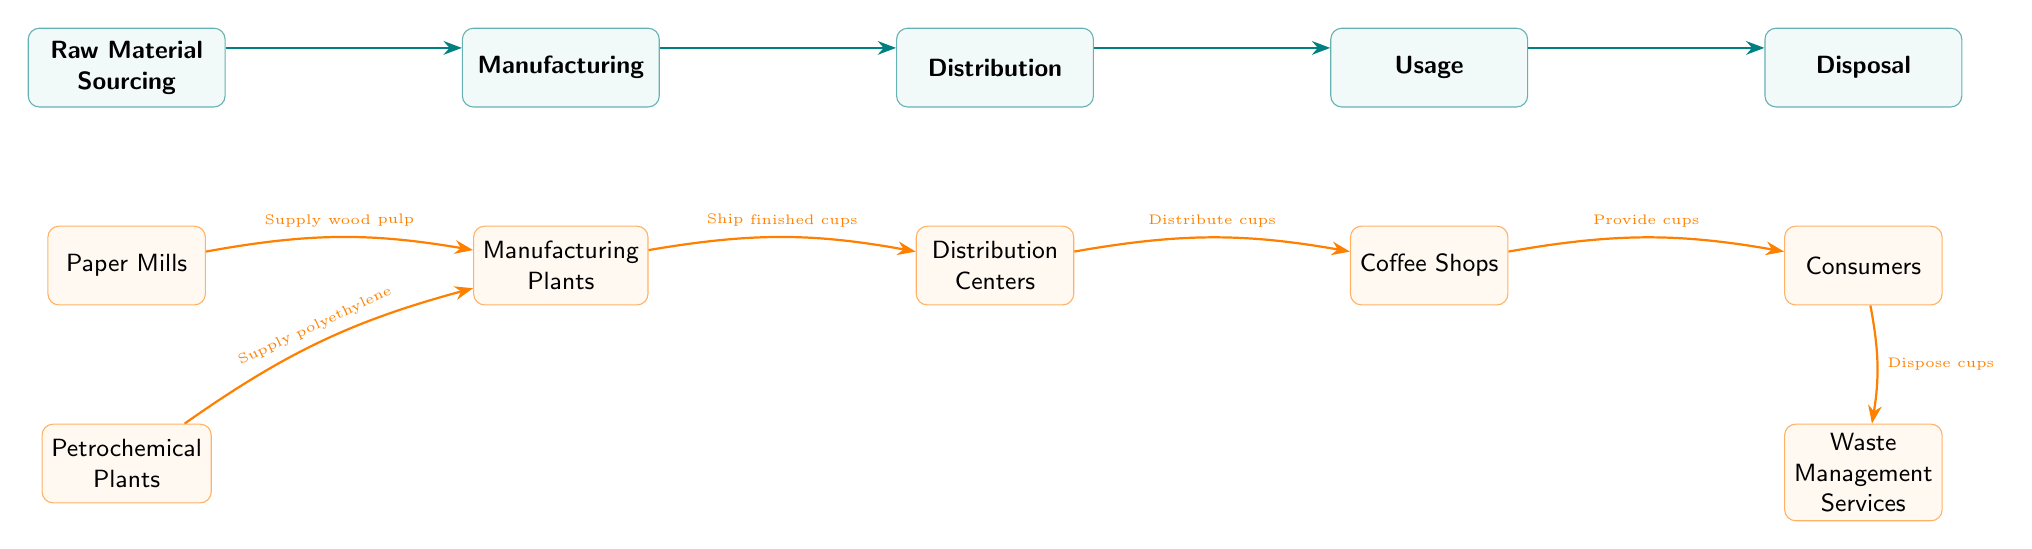What is the first stage in the lifecycle of a disposable coffee cup? The first stage listed in the diagram is "Raw Material Sourcing". This is the starting point of the lifecycle, indicating where materials for manufacturing begin their journey.
Answer: Raw Material Sourcing How many main stages are there in the lifecycle? The diagram shows five main stages: Raw Material Sourcing, Manufacturing, Distribution, Usage, and Disposal. Counting these stages gives a total of five.
Answer: 5 What is supplied by paper mills to manufacturing plants? The arrow from "Paper Mills" to "Manufacturing Plants" indicates that "wood pulp" is supplied from the paper mills, which is a critical raw material for making disposable coffee cups.
Answer: wood pulp Where do consumers obtain disposable coffee cups? According to the diagram, consumers obtain disposable coffee cups from "Coffee Shops". This stage shows the distribution of cups directly to the end users.
Answer: Coffee Shops Which stage follows the usage of disposable coffee cups? The transition from "Usage" to "Disposal" in the diagram shows that the stage that follows usage is disposal. This indicates what happens to the cups after they are used.
Answer: Disposal What is the last process involved in the lifecycle? The last process in the lifecycle, as shown in the diagram, is "Waste Management Services". This is the final destination for the cups after they are disposed of by consumers.
Answer: Waste Management Services What is provided to consumers at the usage stage? The usage stage indicates that "cups" are provided to consumers. This directly addresses what is the key output of the usage phase in the lifecycle.
Answer: cups Which two processes supply materials to manufacturing plants? The processes that supply materials to manufacturing plants are "Paper Mills," which supply wood pulp, and "Petrochemical Plants," which supply polyethylene. This demonstrates a multi-source supply chain.
Answer: Paper Mills and Petrochemical Plants How do cups reach coffee shops after manufacturing? The diagram shows that cups are shipped from "Manufacturing Plants" to "Distribution Centers," and then distributed to "Coffee Shops." This sequence illustrates the logistical flow of products.
Answer: Ship finished cups and Distribute cups 